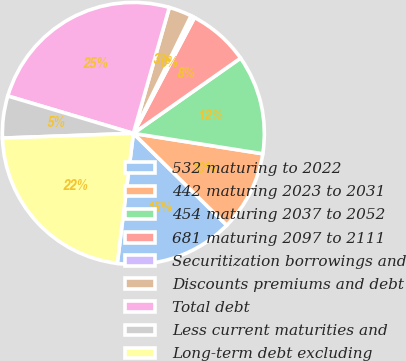Convert chart to OTSL. <chart><loc_0><loc_0><loc_500><loc_500><pie_chart><fcel>532 maturing to 2022<fcel>442 maturing 2023 to 2031<fcel>454 maturing 2037 to 2052<fcel>681 maturing 2097 to 2111<fcel>Securitization borrowings and<fcel>Discounts premiums and debt<fcel>Total debt<fcel>Less current maturities and<fcel>Long-term debt excluding<nl><fcel>14.59%<fcel>9.88%<fcel>12.23%<fcel>7.53%<fcel>0.47%<fcel>2.83%<fcel>24.82%<fcel>5.18%<fcel>22.47%<nl></chart> 